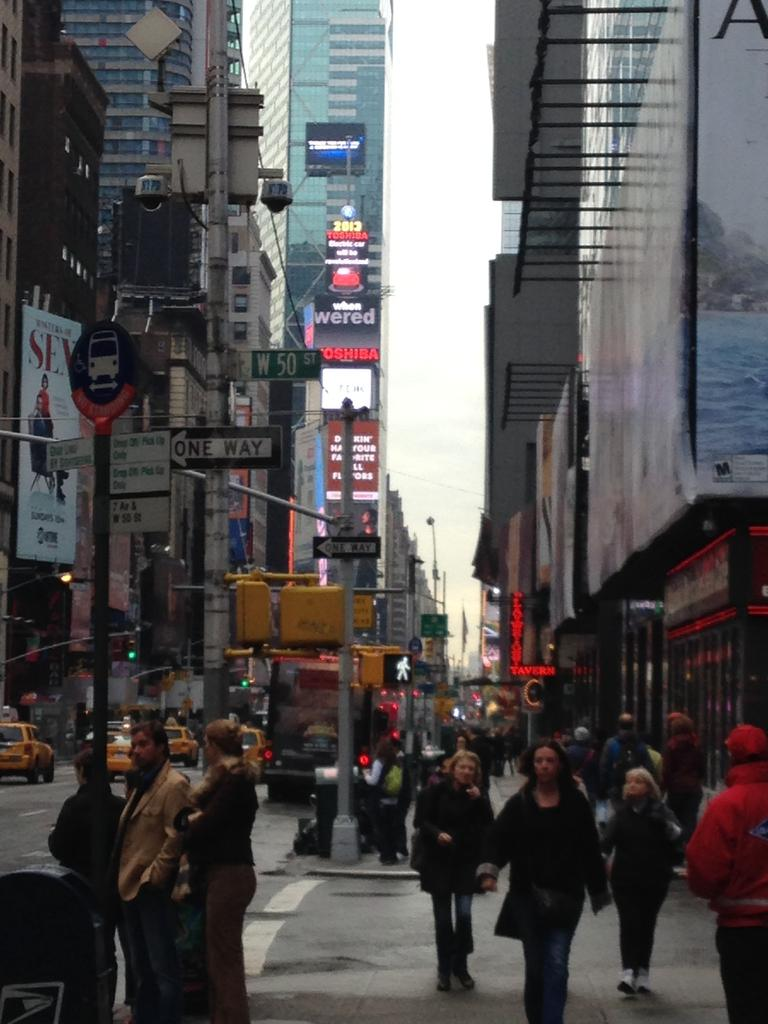Who or what can be seen in the image? There are people in the image. What else is visible in the image besides people? There are cars and poles in the image. What type of structures are present in the middle of the image? Buildings are present in the middle of the image. What can be seen in the background of the image? The sky is visible in the background of the image. What degree of muscle strength is required to lift the poles in the image? There is no information about the weight or size of the poles in the image, so it is impossible to determine the degree of muscle strength required to lift them. 